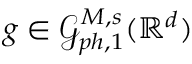Convert formula to latex. <formula><loc_0><loc_0><loc_500><loc_500>g \in \mathcal { G } _ { p h , 1 } ^ { M , s } ( \mathbb { R } ^ { d } )</formula> 